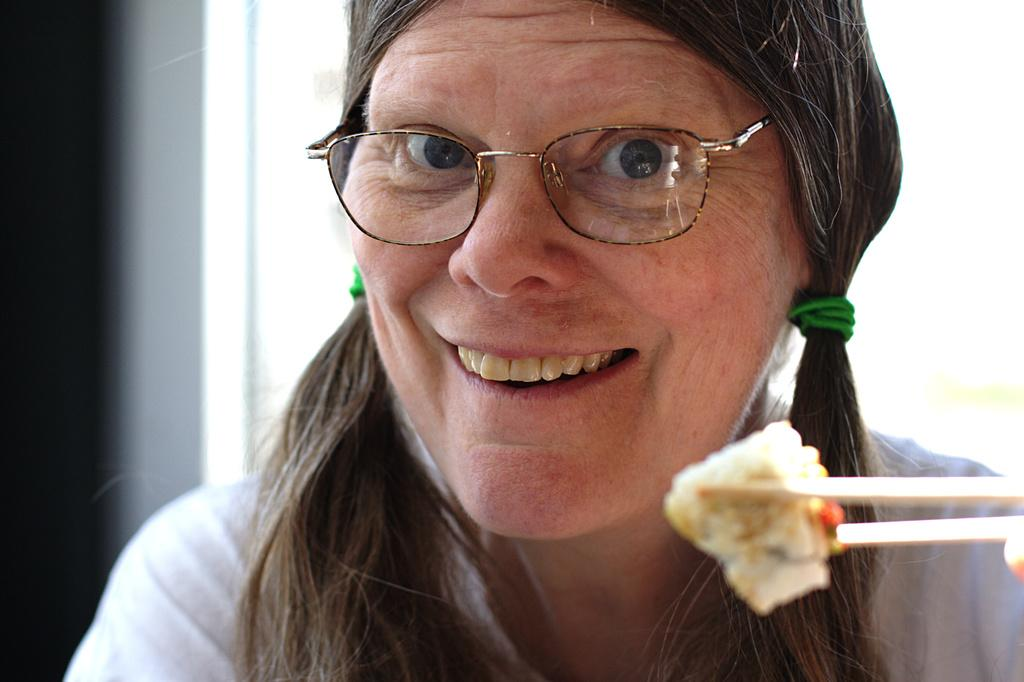Who is the main subject in the image? There is a woman in the image. What is the woman wearing on her face? The woman is wearing spectacles. What is the woman's facial expression in the image? The woman is smiling. What is the weather like in the image? The provided facts do not mention any information about the weather, so it cannot be determined from the image. 